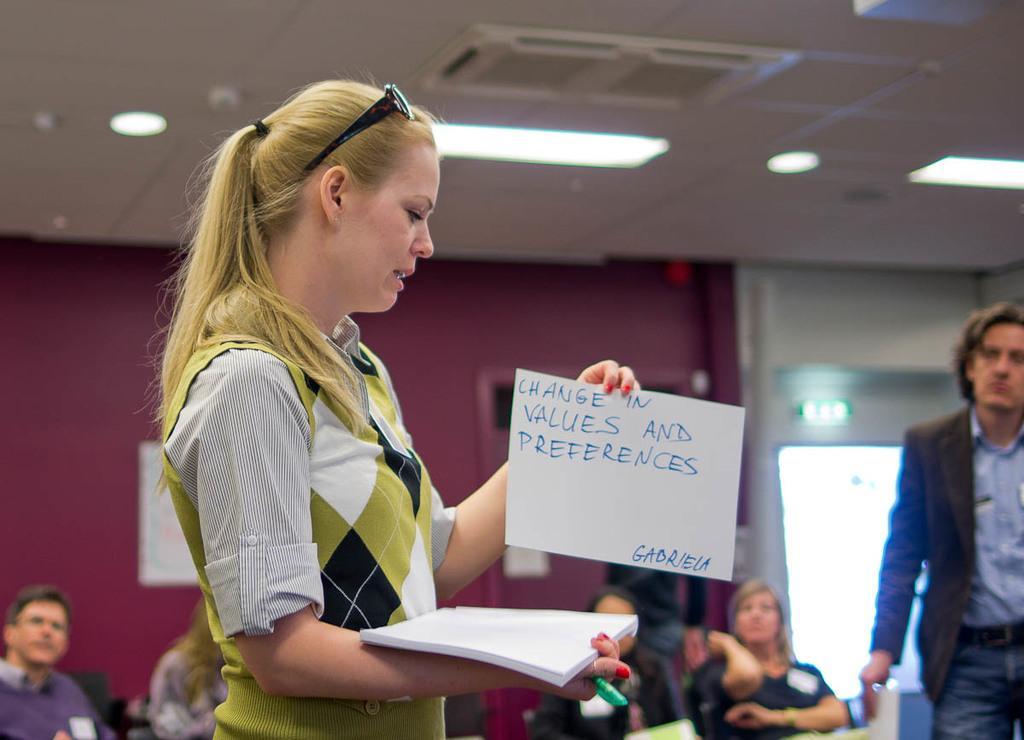Could you give a brief overview of what you see in this image? In this picture there is a girl wearing white and green color sweater, holding the white papers in the hand. Behind there is a red color wall and a group of men and women looking to her. On the right side there is a man wearing black color and blue shirt watching to the girl. Above on the ceiling there are some spotlights. 